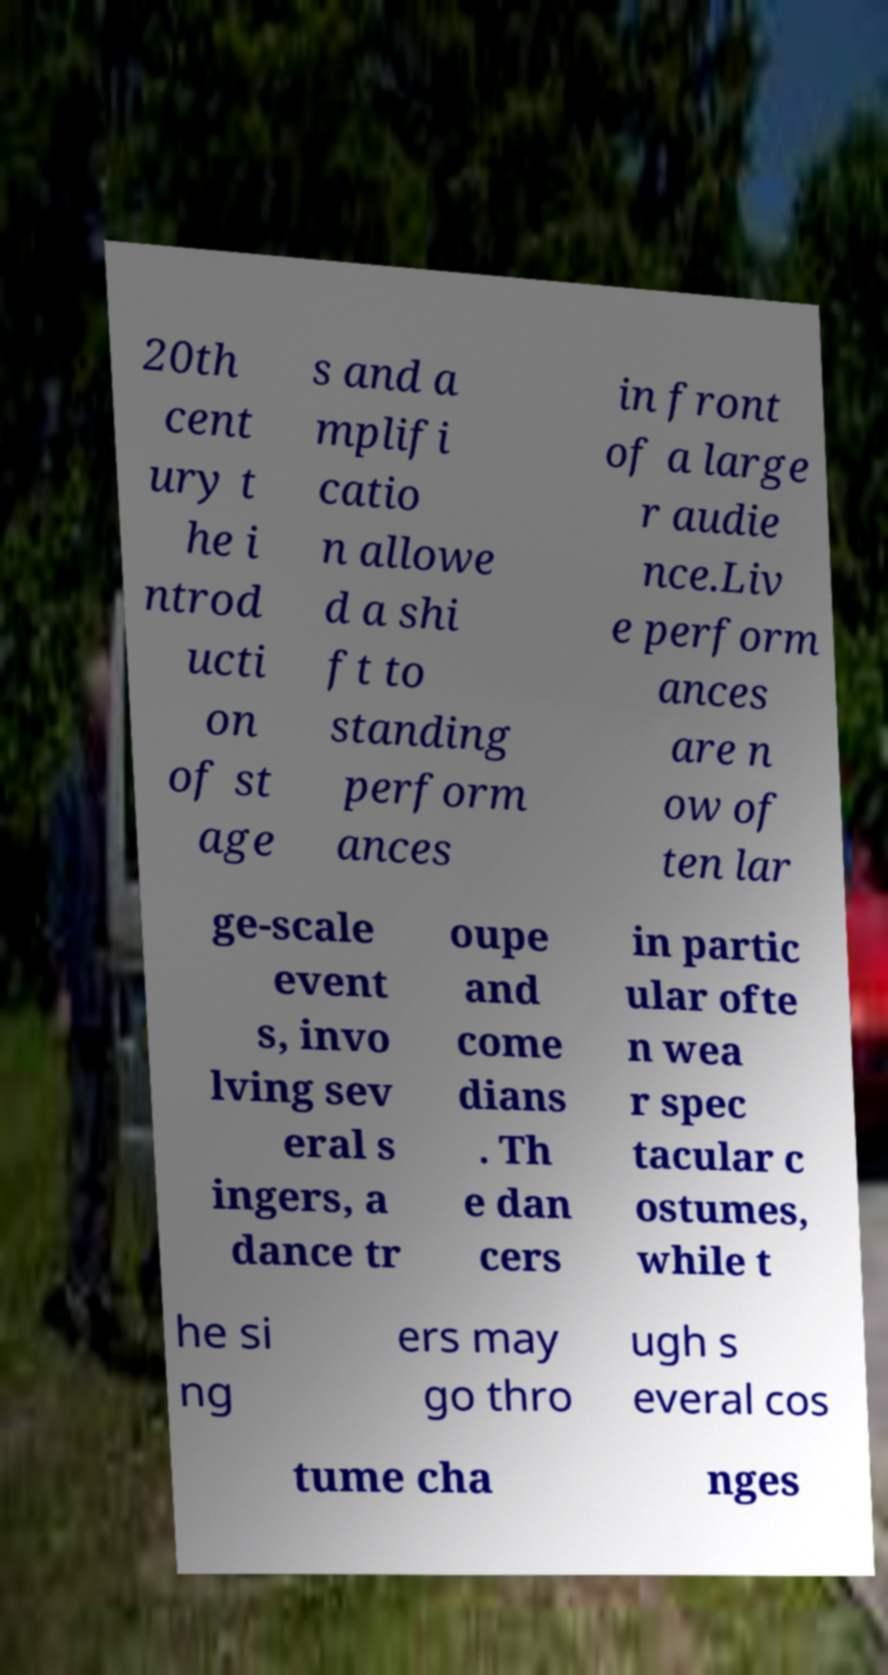I need the written content from this picture converted into text. Can you do that? 20th cent ury t he i ntrod ucti on of st age s and a mplifi catio n allowe d a shi ft to standing perform ances in front of a large r audie nce.Liv e perform ances are n ow of ten lar ge-scale event s, invo lving sev eral s ingers, a dance tr oupe and come dians . Th e dan cers in partic ular ofte n wea r spec tacular c ostumes, while t he si ng ers may go thro ugh s everal cos tume cha nges 